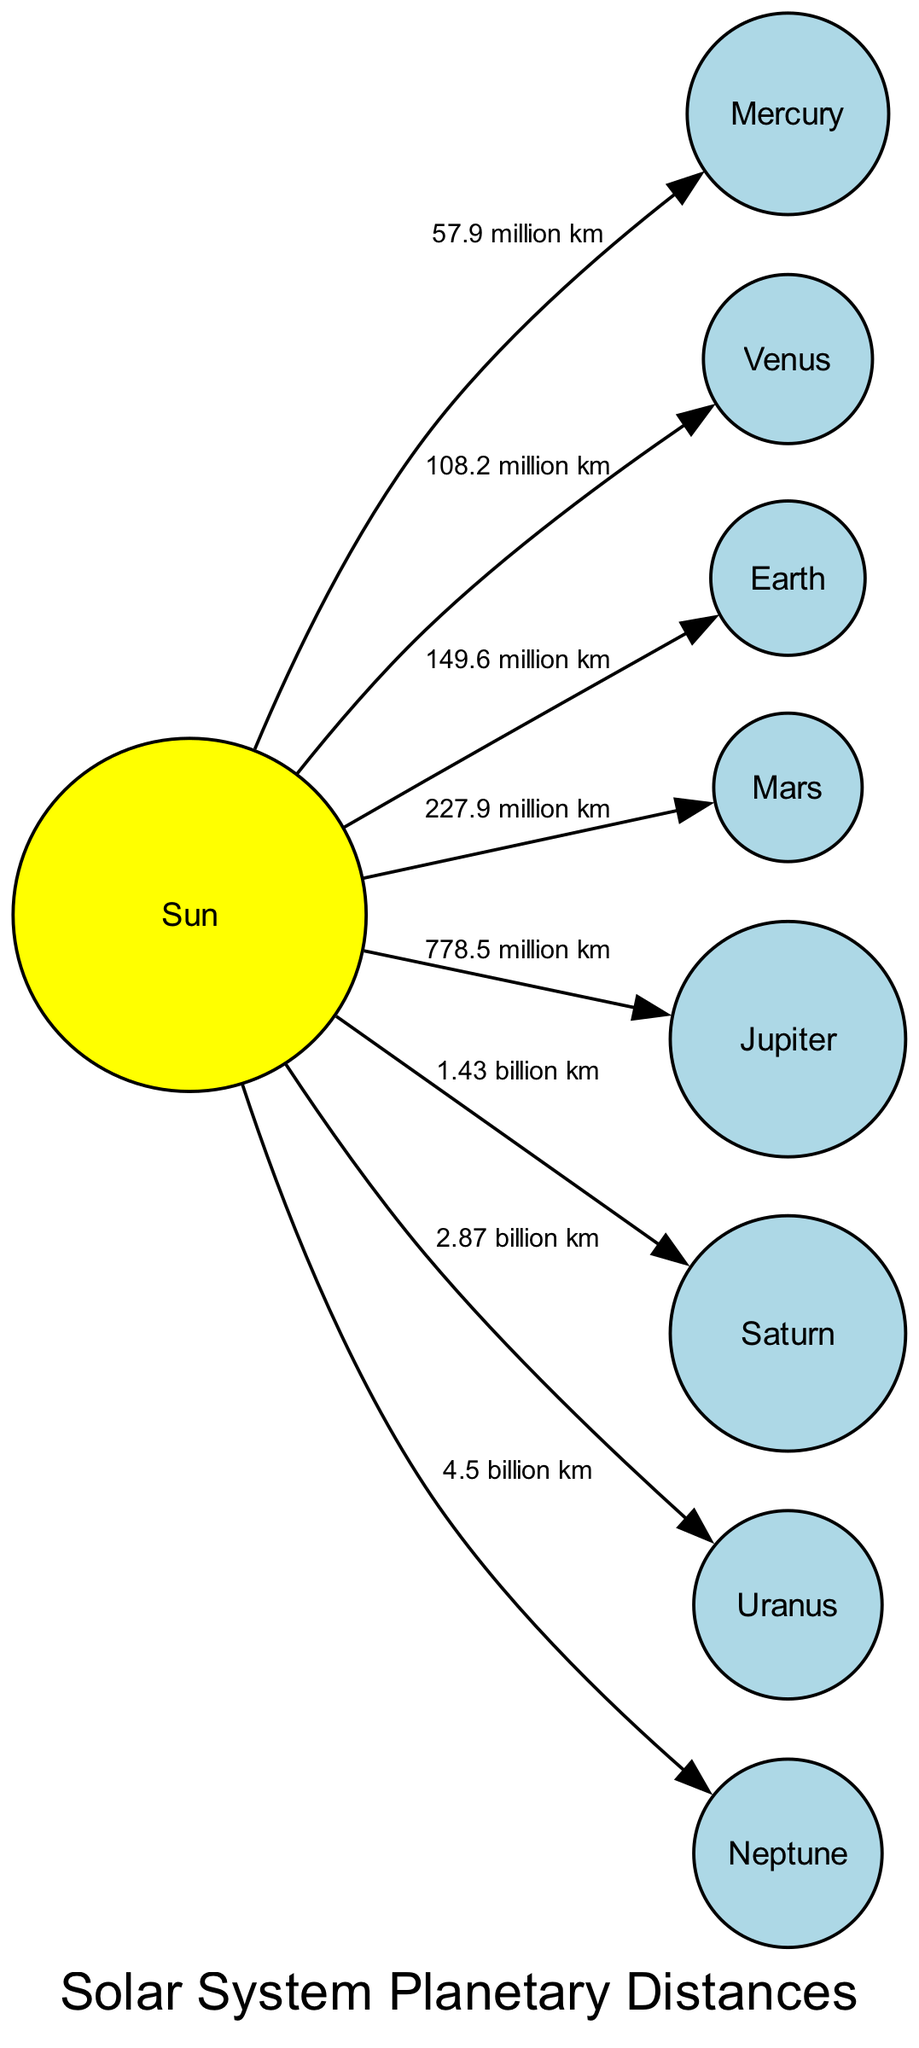What planet is closest to the Sun? The diagram displays the nodes representing the planets and their distances from the Sun. By identifying the node labeled "Mercury" as the closest planet, I can confirm it is indeed the closest to the Sun.
Answer: Mercury What distance separates Neptune from the Sun? The edge connecting Neptune to the Sun shows the distance labeled "4.5 billion km". Therefore, by inspecting this edge, I can directly answer the question about the distance.
Answer: 4.5 billion km Which planet has a thick, toxic atmosphere? In the nodes, if I look for the planet that is described with a specific detail regarding its atmosphere, I find "Venus" as the one with a thick, toxic atmosphere.
Answer: Venus How many planets are shown in the diagram? To find the number of planets, I count the nodes that are classified as planets, excluding the Sun. There are eight nodes in total, out of which seven represent planets.
Answer: 8 What is the average distance of the four inner planets from the Sun? I find the distances of Mercury (57.9 million km), Venus (108.2 million km), Earth (149.6 million km), and Mars (227.9 million km). Adding these yields 543.6 million km. Dividing by 4 gives me an average of 135.9 million km.
Answer: 135.9 million km What planet is known as the Red Planet? According to the diagram, "Mars" is specifically labeled as the Red Planet, indicating its well-known nickname.
Answer: Mars Which planet is the largest in the Solar System? The diagram highlights "Jupiter" as the largest planet, distinguishing it from all other planets due to its size.
Answer: Jupiter What is the distinctive feature of Saturn? When examining the nodes and their descriptions, "Saturn" is stated to be distinctive for its extensive ring system, which sets it apart from other planets.
Answer: Extensive ring system How far is Earth from the Sun? From the edge connecting Earth to the Sun, the distance is labeled "149.6 million km". This direct labeling on the diagram gives an exact answer for the distance.
Answer: 149.6 million km 